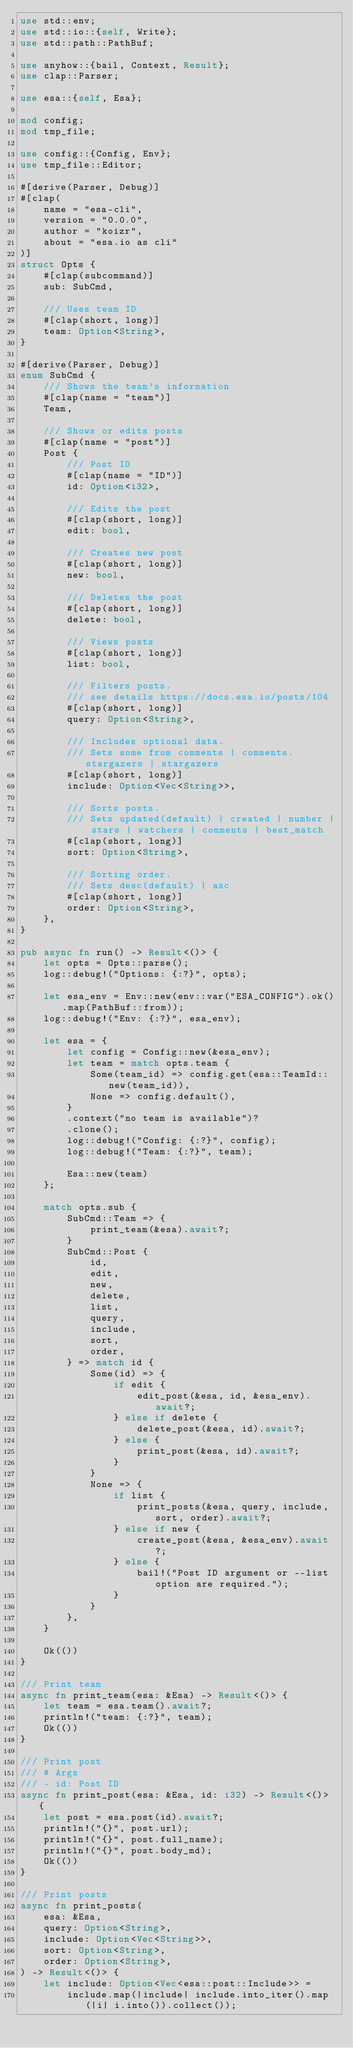<code> <loc_0><loc_0><loc_500><loc_500><_Rust_>use std::env;
use std::io::{self, Write};
use std::path::PathBuf;

use anyhow::{bail, Context, Result};
use clap::Parser;

use esa::{self, Esa};

mod config;
mod tmp_file;

use config::{Config, Env};
use tmp_file::Editor;

#[derive(Parser, Debug)]
#[clap(
    name = "esa-cli",
    version = "0.0.0",
    author = "koizr",
    about = "esa.io as cli"
)]
struct Opts {
    #[clap(subcommand)]
    sub: SubCmd,

    /// Uses team ID
    #[clap(short, long)]
    team: Option<String>,
}

#[derive(Parser, Debug)]
enum SubCmd {
    /// Shows the team's information
    #[clap(name = "team")]
    Team,

    /// Shows or edits posts
    #[clap(name = "post")]
    Post {
        /// Post ID
        #[clap(name = "ID")]
        id: Option<i32>,

        /// Edits the post
        #[clap(short, long)]
        edit: bool,

        /// Creates new post
        #[clap(short, long)]
        new: bool,

        /// Deletes the post
        #[clap(short, long)]
        delete: bool,

        /// Views posts
        #[clap(short, long)]
        list: bool,

        /// Filters posts.
        /// see details https://docs.esa.io/posts/104
        #[clap(short, long)]
        query: Option<String>,

        /// Includes optional data.
        /// Sets some from comments | comments.stargazers | stargazers
        #[clap(short, long)]
        include: Option<Vec<String>>,

        /// Sorts posts.
        /// Sets updated(default) | created | number | stars | watchers | comments | best_match
        #[clap(short, long)]
        sort: Option<String>,

        /// Sorting order.
        /// Sets desc(default) | asc
        #[clap(short, long)]
        order: Option<String>,
    },
}

pub async fn run() -> Result<()> {
    let opts = Opts::parse();
    log::debug!("Options: {:?}", opts);

    let esa_env = Env::new(env::var("ESA_CONFIG").ok().map(PathBuf::from));
    log::debug!("Env: {:?}", esa_env);

    let esa = {
        let config = Config::new(&esa_env);
        let team = match opts.team {
            Some(team_id) => config.get(esa::TeamId::new(team_id)),
            None => config.default(),
        }
        .context("no team is available")?
        .clone();
        log::debug!("Config: {:?}", config);
        log::debug!("Team: {:?}", team);

        Esa::new(team)
    };

    match opts.sub {
        SubCmd::Team => {
            print_team(&esa).await?;
        }
        SubCmd::Post {
            id,
            edit,
            new,
            delete,
            list,
            query,
            include,
            sort,
            order,
        } => match id {
            Some(id) => {
                if edit {
                    edit_post(&esa, id, &esa_env).await?;
                } else if delete {
                    delete_post(&esa, id).await?;
                } else {
                    print_post(&esa, id).await?;
                }
            }
            None => {
                if list {
                    print_posts(&esa, query, include, sort, order).await?;
                } else if new {
                    create_post(&esa, &esa_env).await?;
                } else {
                    bail!("Post ID argument or --list option are required.");
                }
            }
        },
    }

    Ok(())
}

/// Print team
async fn print_team(esa: &Esa) -> Result<()> {
    let team = esa.team().await?;
    println!("team: {:?}", team);
    Ok(())
}

/// Print post
/// # Args
/// - id: Post ID
async fn print_post(esa: &Esa, id: i32) -> Result<()> {
    let post = esa.post(id).await?;
    println!("{}", post.url);
    println!("{}", post.full_name);
    println!("{}", post.body_md);
    Ok(())
}

/// Print posts
async fn print_posts(
    esa: &Esa,
    query: Option<String>,
    include: Option<Vec<String>>,
    sort: Option<String>,
    order: Option<String>,
) -> Result<()> {
    let include: Option<Vec<esa::post::Include>> =
        include.map(|include| include.into_iter().map(|i| i.into()).collect());</code> 